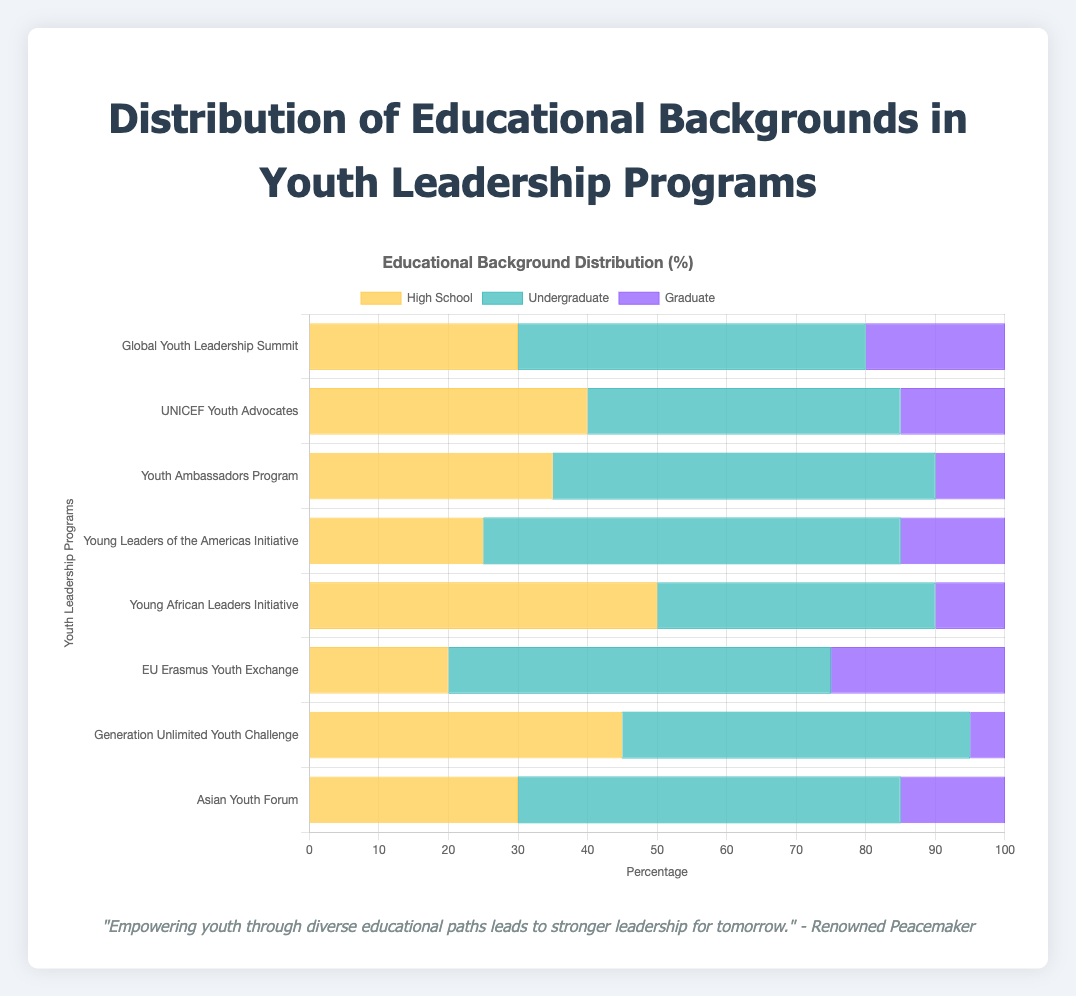Which program has the highest percentage of participants with an undergraduate background? To find the program with the highest percentage of participants with an undergraduate background, we compare the undergraduate percentages for all programs. The data shows that the "Young Leaders of the Americas Initiative" has the highest percentage at 60%.
Answer: Young Leaders of the Americas Initiative What is the total percentage of participants with graduate backgrounds in the "EU Erasmus Youth Exchange" and "Global Youth Leadership Summit" programs? Add the graduate percentages from both programs: EU Erasmus Youth Exchange (25%) + Global Youth Leadership Summit (20%) = 45%.
Answer: 45% How does the percentage of high school participants in the "Young African Leaders Initiative" compare to that in the "EU Erasmus Youth Exchange"? Comparing the percentages, the "Young African Leaders Initiative" has 50% high school participants, while the "EU Erasmus Youth Exchange" has 20%. 50% is greater than 20%.
Answer: Young African Leaders Initiative > EU Erasmus Youth Exchange Which program has the least percentage of graduate participants, and what is that percentage? Compare the graduate percentages for all programs. The "Generation Unlimited Youth Challenge" has the least percentage of graduate participants at 5%.
Answer: Generation Unlimited Youth Challenge, 5% What is the average percentage of undergraduate participants across all programs? To find the average, sum the undergraduate percentages for all programs and divide by the number of programs: (50 + 45 + 55 + 60 + 40 + 55 + 50 + 55) / 8 = 51.25%.
Answer: 51.25% How does the combined percentage of high school and undergraduate participants in the "UNICEF Youth Advocates" program compare to the combined percentage in the "Youth Ambassadors Program"? Calculate the combined percentages for each program: UNICEF Youth Advocates (40% + 45% = 85%) and Youth Ambassadors Program (35% + 55% = 90%). 90% is greater than 85%.
Answer: Youth Ambassadors Program > UNICEF Youth Advocates What is the difference in the percentage of graduate participants between the "Asian Youth Forum" and the "Youth Ambassadors Program"? Subtract the percentage of graduate participants in the Youth Ambassadors Program (10%) from that in the Asian Youth Forum (15%): 15% - 10% = 5%.
Answer: 5% Which programs have exactly 15% graduate participants? Identify the programs with 15% graduate participants. The programs are "UNICEF Youth Advocates", "Young Leaders of the Americas Initiative", and "Asian Youth Forum".
Answer: UNICEF Youth Advocates, Young Leaders of the Americas Initiative, Asian Youth Forum What is the total percentage of all educational backgrounds in the "Young Leaders of the Americas Initiative"? Add the high school, undergraduate, and graduate percentages for the program: 25% + 60% + 15% = 100%.
Answer: 100% Between the "Global Youth Leadership Summit" and the "Youth Ambassadors Program," which has a higher percentage of high school participants and by how much? Compare the high school percentages: Global Youth Leadership Summit (30%) and Youth Ambassadors Program (35%). 35% - 30% = 5%. The Youth Ambassadors Program has a higher percentage by 5%.
Answer: Youth Ambassadors Program, 5% 